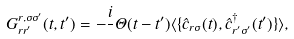<formula> <loc_0><loc_0><loc_500><loc_500>G ^ { r , \sigma \sigma ^ { \prime } } _ { r r ^ { \prime } } ( t , t ^ { \prime } ) = - \frac { i } { } \Theta ( t - t ^ { \prime } ) \langle \{ \hat { c } _ { { r } \sigma } ( t ) , \hat { c } ^ { \dagger } _ { { r ^ { \prime } } \sigma ^ { \prime } } ( t ^ { \prime } ) \} \rangle ,</formula> 